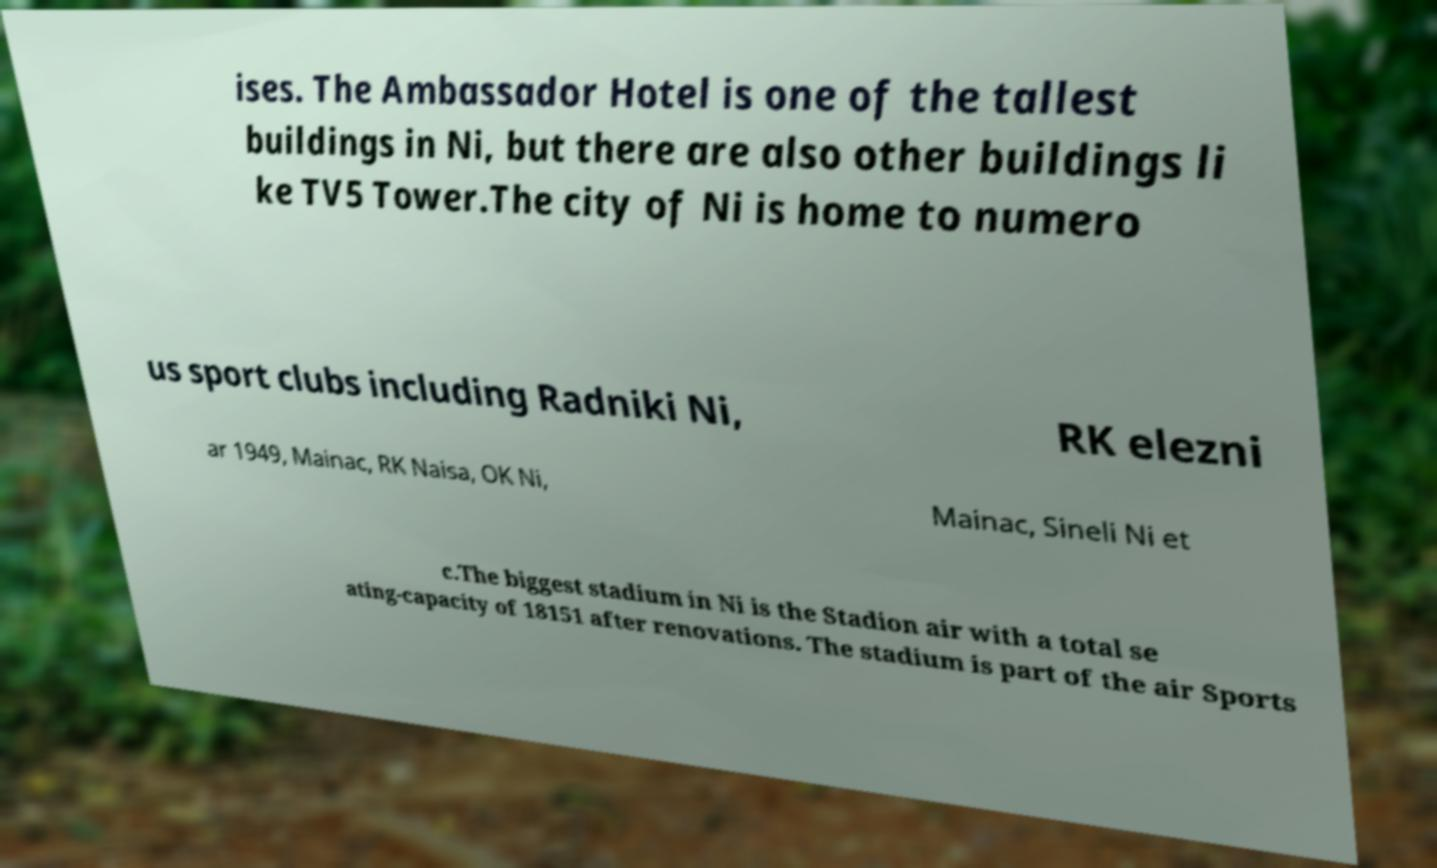Could you assist in decoding the text presented in this image and type it out clearly? ises. The Ambassador Hotel is one of the tallest buildings in Ni, but there are also other buildings li ke TV5 Tower.The city of Ni is home to numero us sport clubs including Radniki Ni, RK elezni ar 1949, Mainac, RK Naisa, OK Ni, Mainac, Sineli Ni et c.The biggest stadium in Ni is the Stadion air with a total se ating-capacity of 18151 after renovations. The stadium is part of the air Sports 